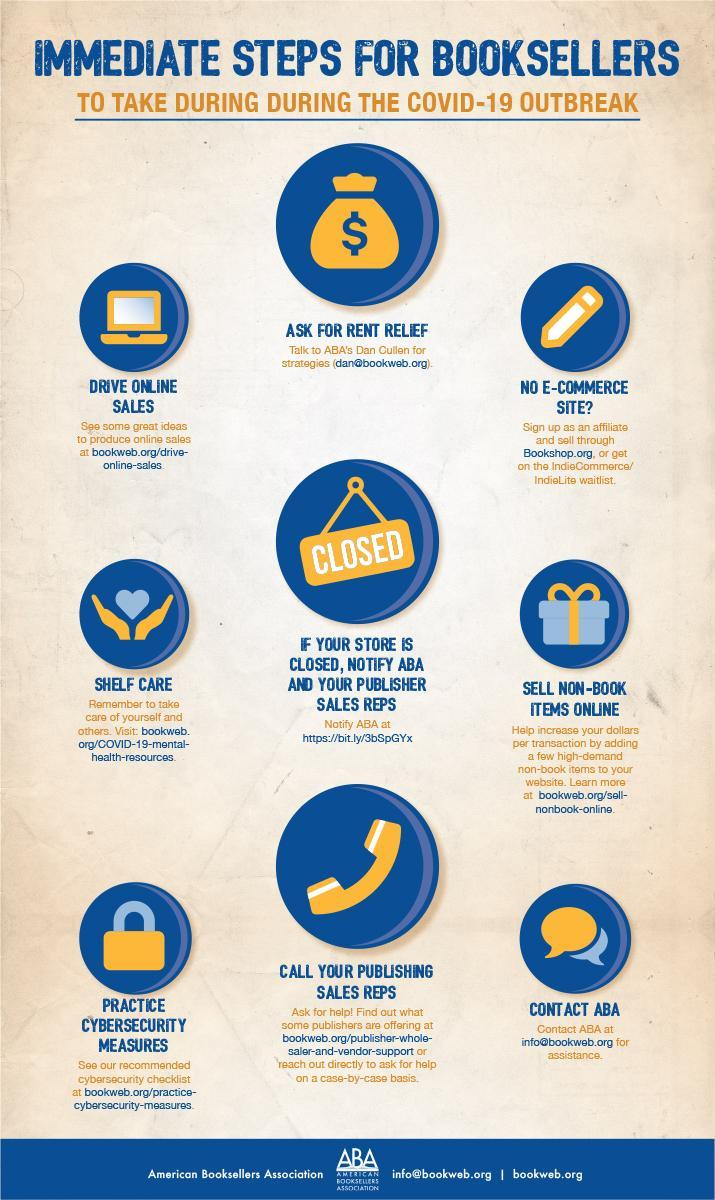How many steps the booksellers have to take during the covid-19 outbreak?
Answer the question with a short phrase. 9 